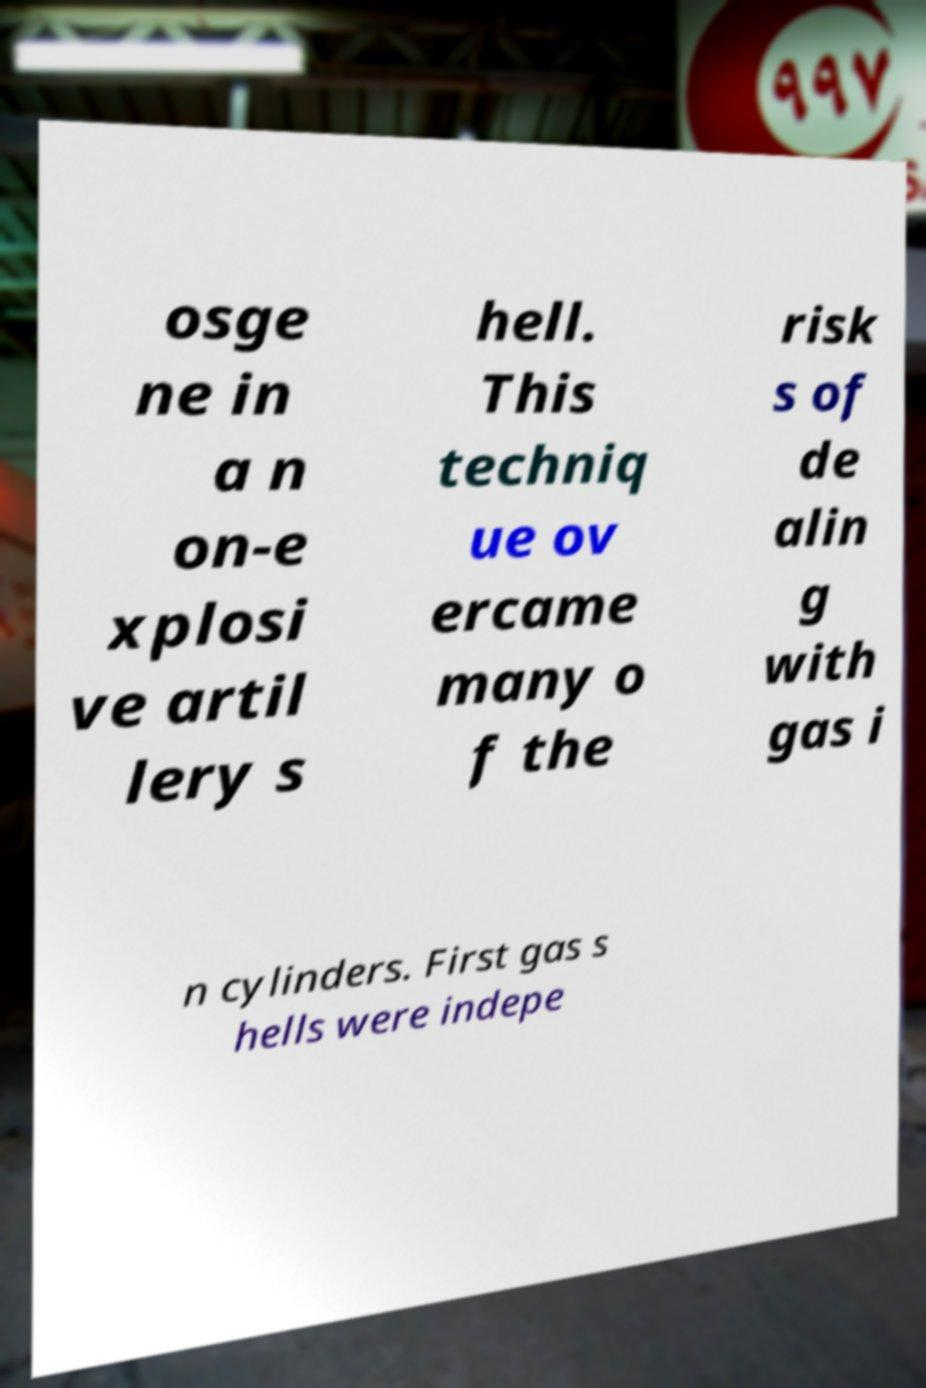Please identify and transcribe the text found in this image. osge ne in a n on-e xplosi ve artil lery s hell. This techniq ue ov ercame many o f the risk s of de alin g with gas i n cylinders. First gas s hells were indepe 